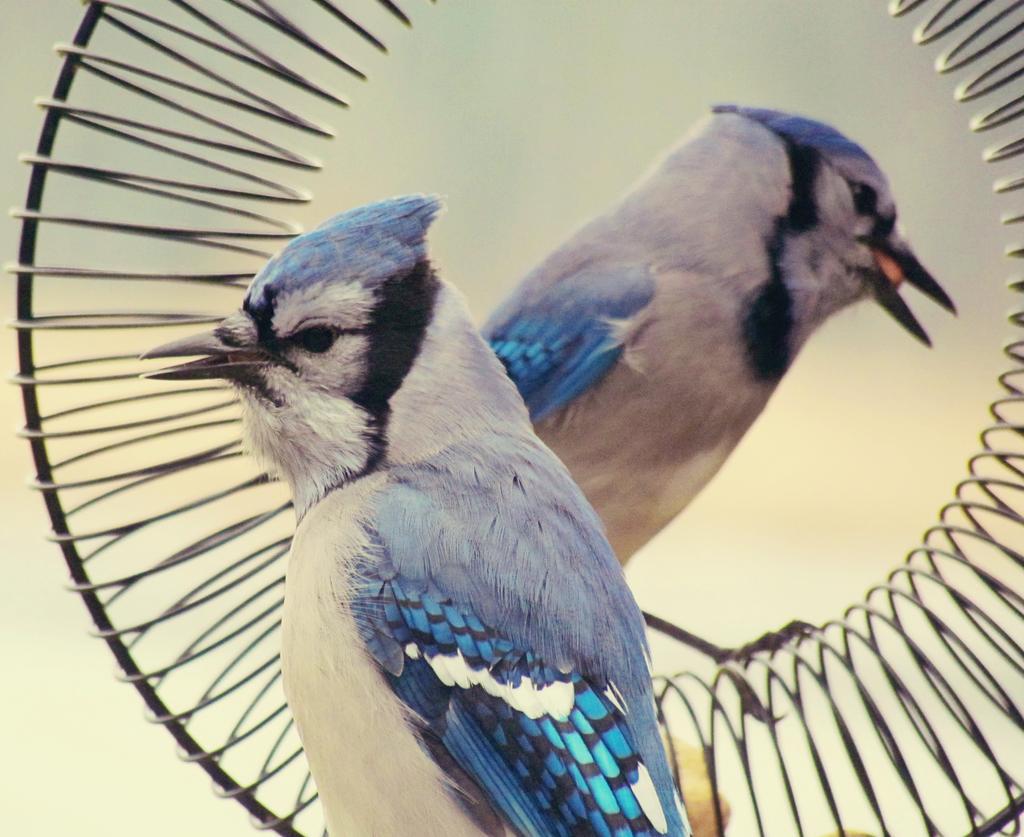In one or two sentences, can you explain what this image depicts? In the picture I can see two birds and in the background I can see some object which is in round shape. The background of the image is blurred. 